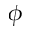<formula> <loc_0><loc_0><loc_500><loc_500>\phi</formula> 